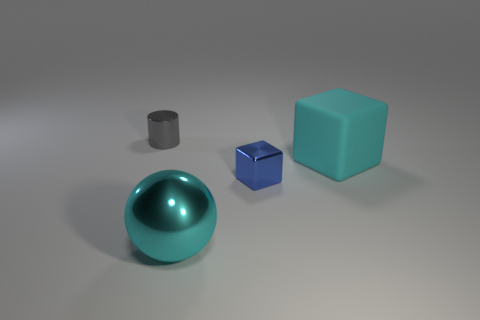Is the material of the tiny object on the right side of the small gray cylinder the same as the object that is on the right side of the small blue cube?
Your response must be concise. No. There is a large object that is on the right side of the tiny thing that is right of the big cyan metallic object; what is its shape?
Make the answer very short. Cube. Is there any other thing that has the same color as the large rubber thing?
Make the answer very short. Yes. Are there any blocks right of the big cyan thing that is right of the tiny object that is to the right of the cylinder?
Give a very brief answer. No. Do the big thing to the right of the large ball and the object behind the large cyan block have the same color?
Your answer should be compact. No. What material is the gray thing that is the same size as the blue shiny thing?
Your answer should be compact. Metal. There is a thing in front of the small object that is right of the shiny object that is behind the cyan rubber object; what is its size?
Offer a very short reply. Large. What number of other things are there of the same material as the big cyan ball
Provide a short and direct response. 2. What size is the cyan thing on the right side of the blue cube?
Your answer should be compact. Large. How many objects are both on the right side of the large metallic sphere and on the left side of the big cyan metal thing?
Offer a terse response. 0. 